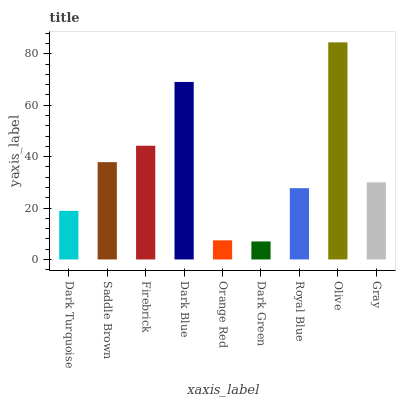Is Dark Green the minimum?
Answer yes or no. Yes. Is Olive the maximum?
Answer yes or no. Yes. Is Saddle Brown the minimum?
Answer yes or no. No. Is Saddle Brown the maximum?
Answer yes or no. No. Is Saddle Brown greater than Dark Turquoise?
Answer yes or no. Yes. Is Dark Turquoise less than Saddle Brown?
Answer yes or no. Yes. Is Dark Turquoise greater than Saddle Brown?
Answer yes or no. No. Is Saddle Brown less than Dark Turquoise?
Answer yes or no. No. Is Gray the high median?
Answer yes or no. Yes. Is Gray the low median?
Answer yes or no. Yes. Is Olive the high median?
Answer yes or no. No. Is Firebrick the low median?
Answer yes or no. No. 